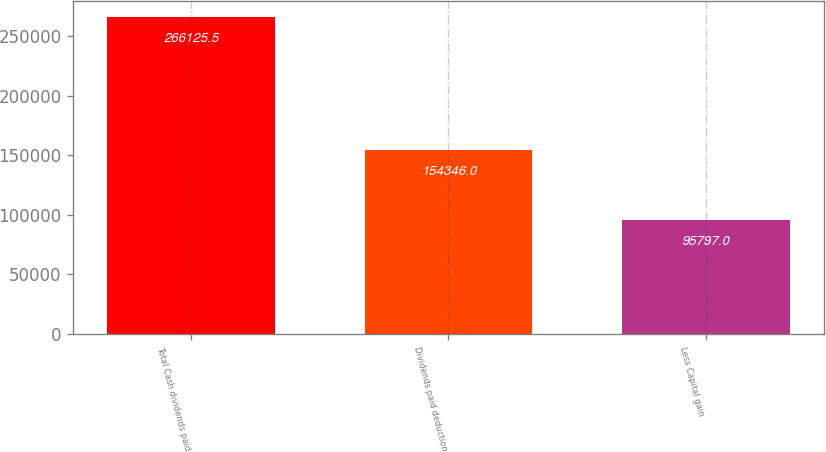Convert chart. <chart><loc_0><loc_0><loc_500><loc_500><bar_chart><fcel>Total Cash dividends paid<fcel>Dividends paid deduction<fcel>Less Capital gain<nl><fcel>266126<fcel>154346<fcel>95797<nl></chart> 